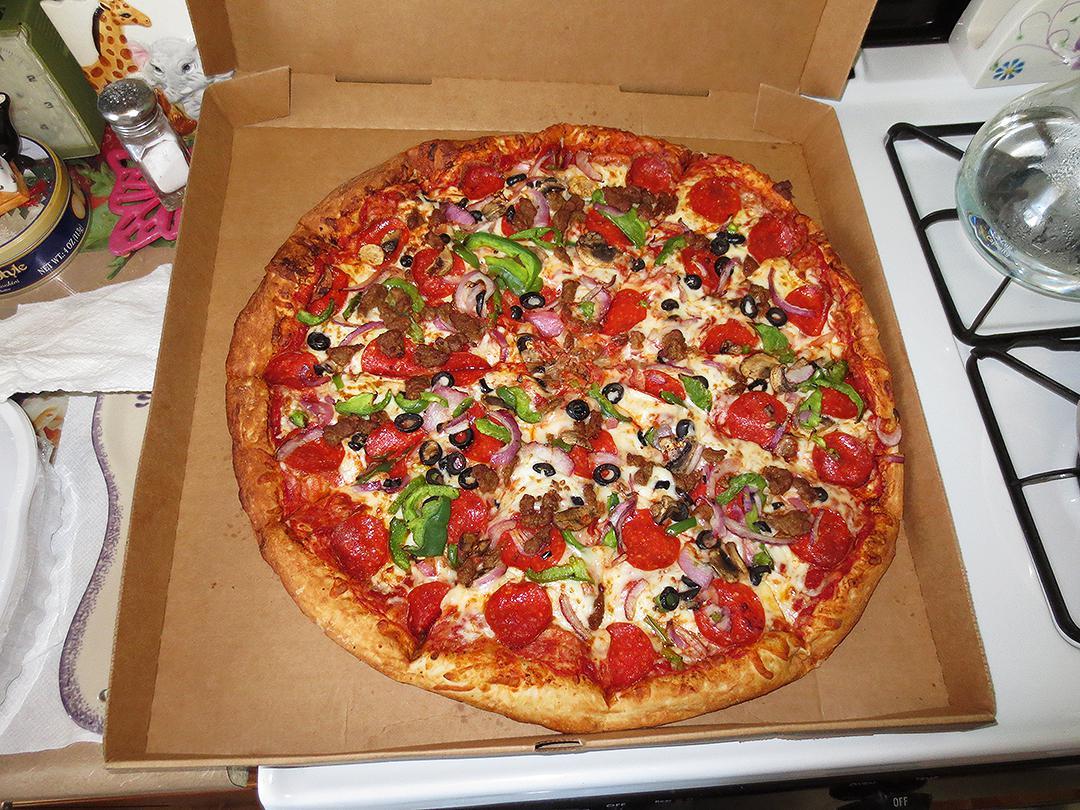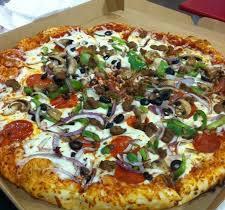The first image is the image on the left, the second image is the image on the right. Considering the images on both sides, is "One image shows al least one pizza slice in a disposable plate and the other shows a full pizza in a brown cardboard box." valid? Answer yes or no. No. The first image is the image on the left, the second image is the image on the right. For the images shown, is this caption "The right image shows a whole sliced pizza in an open box, and the left image shows a triangular slice of pizza on a small round white plate." true? Answer yes or no. No. 